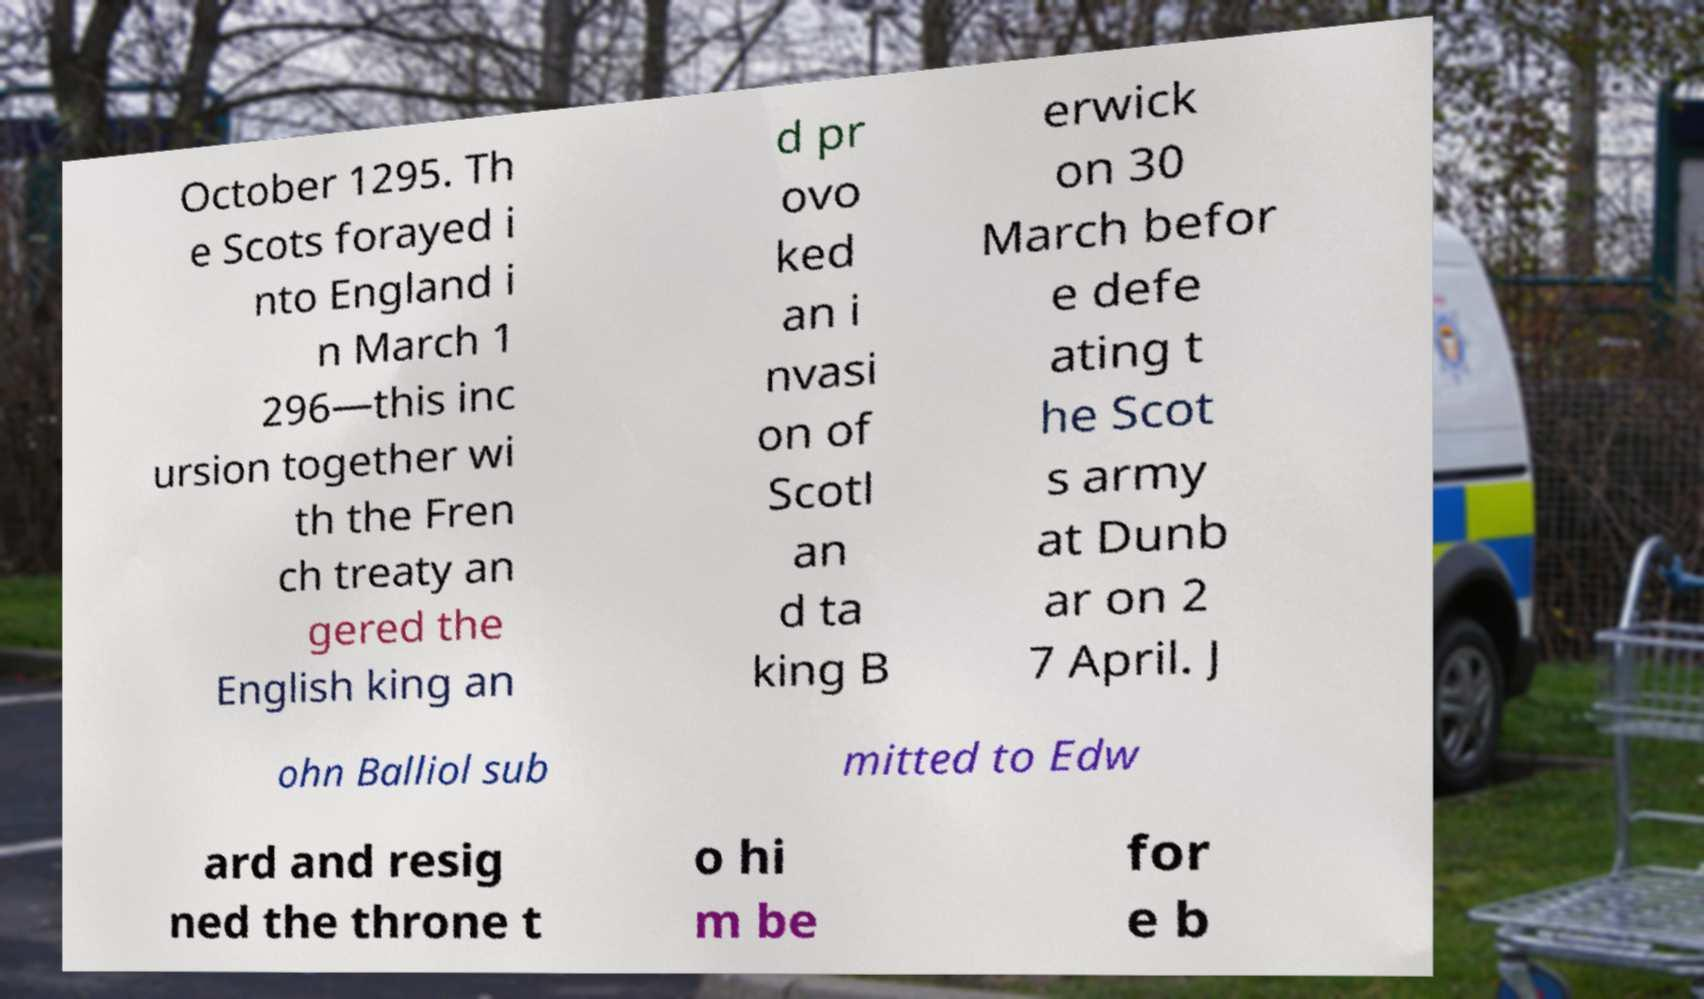There's text embedded in this image that I need extracted. Can you transcribe it verbatim? October 1295. Th e Scots forayed i nto England i n March 1 296—this inc ursion together wi th the Fren ch treaty an gered the English king an d pr ovo ked an i nvasi on of Scotl an d ta king B erwick on 30 March befor e defe ating t he Scot s army at Dunb ar on 2 7 April. J ohn Balliol sub mitted to Edw ard and resig ned the throne t o hi m be for e b 